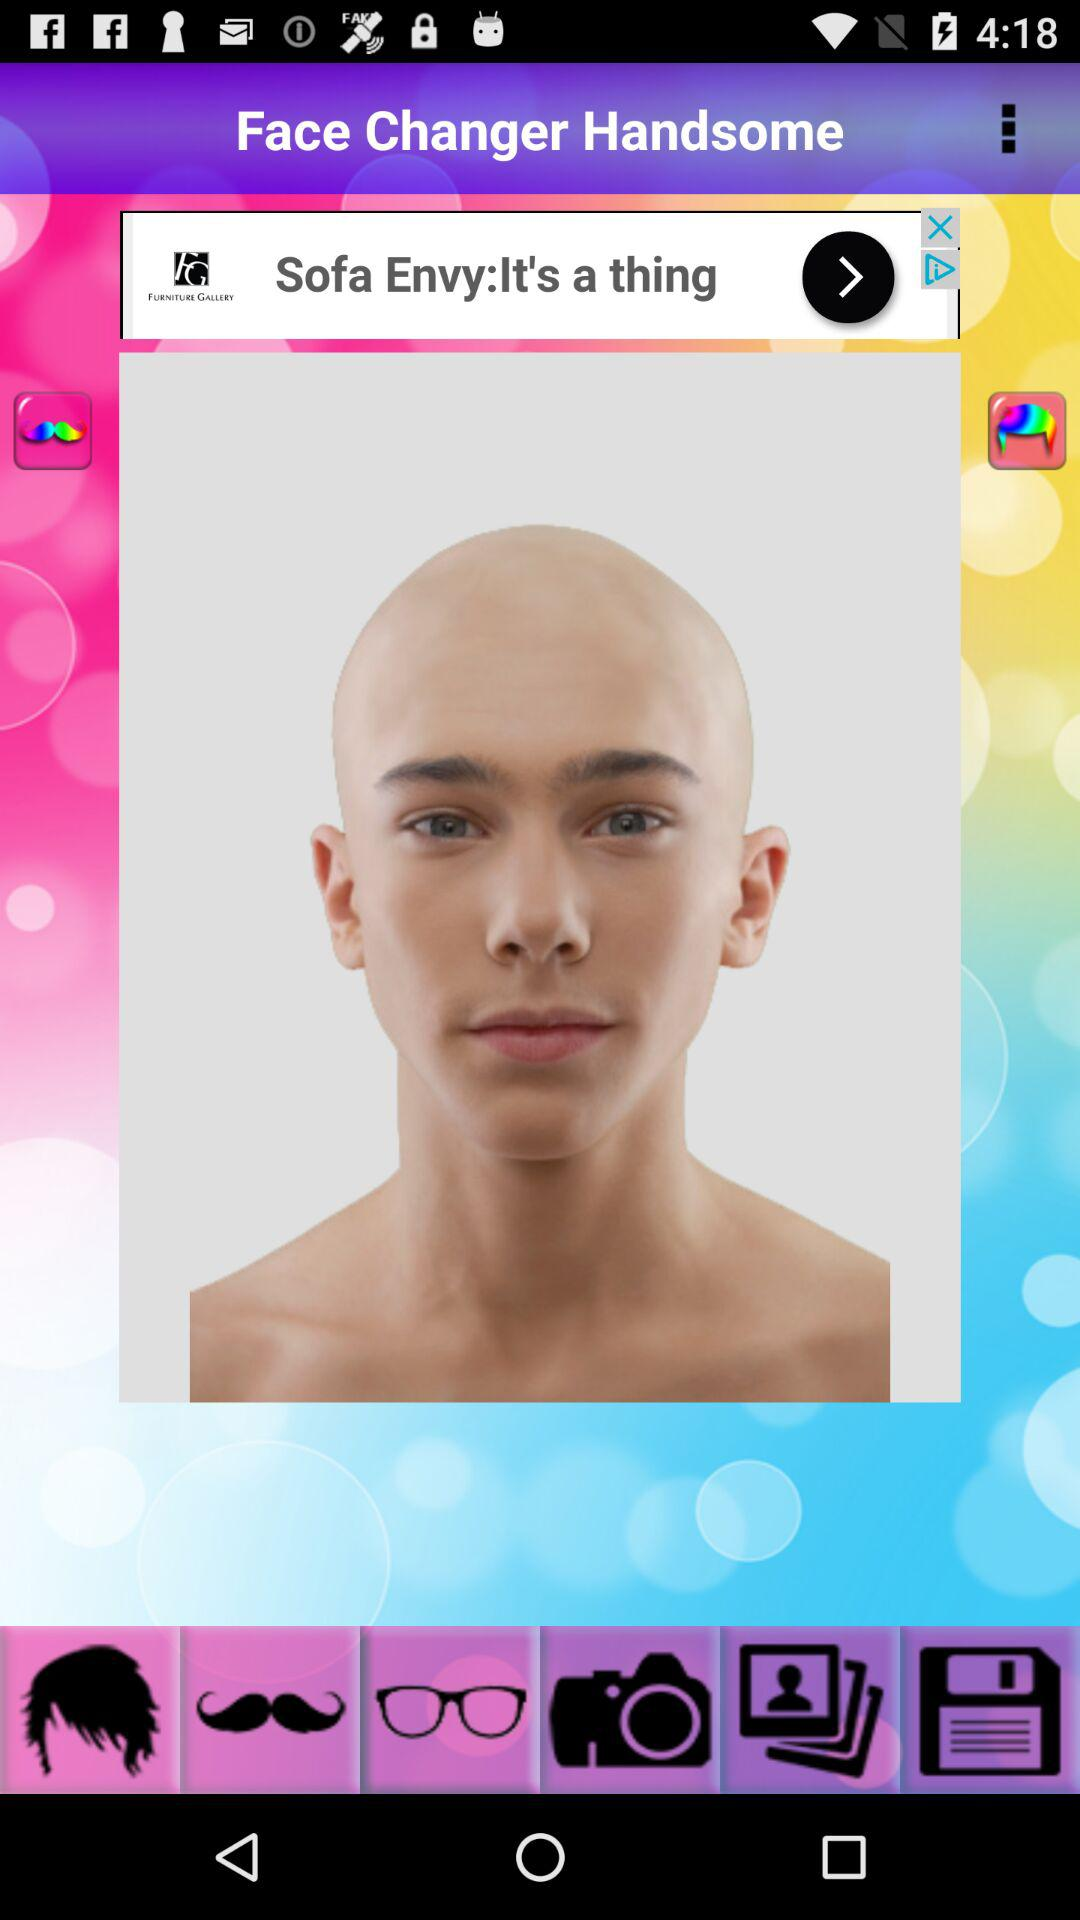What is the name of the application? The name of the application is "Face Changer Handsome". 